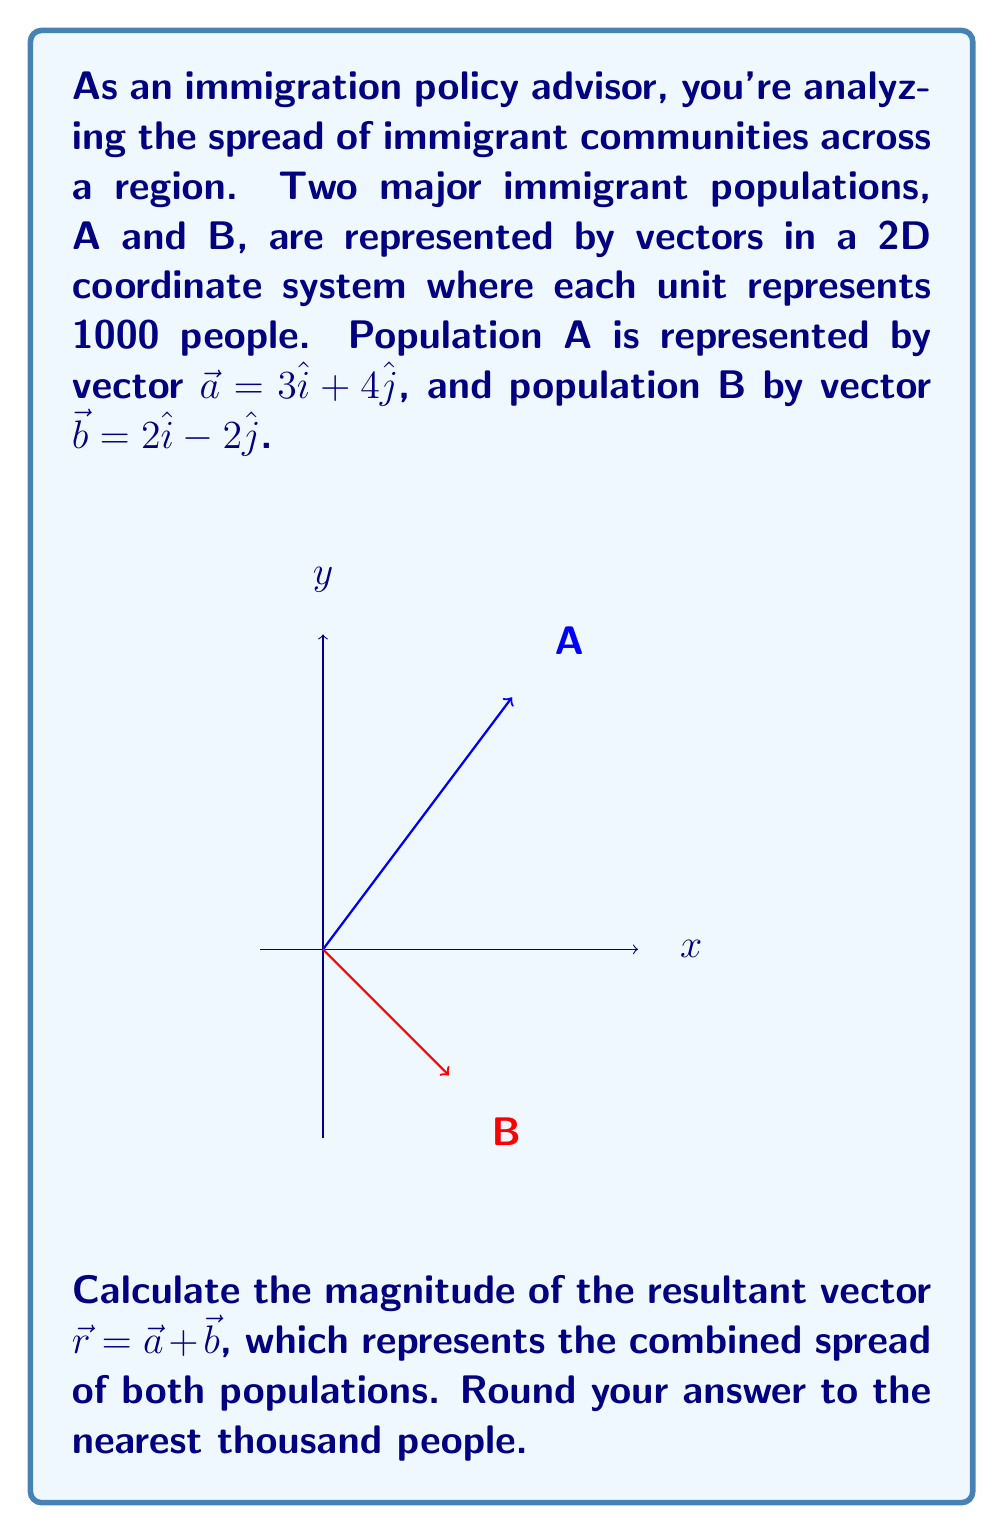Solve this math problem. Let's approach this step-by-step:

1) First, we need to add the two vectors $\vec{a}$ and $\vec{b}$:

   $\vec{r} = \vec{a} + \vec{b} = (3\hat{i} + 4\hat{j}) + (2\hat{i} - 2\hat{j})$

2) Combining like terms:

   $\vec{r} = (3+2)\hat{i} + (4-2)\hat{j} = 5\hat{i} + 2\hat{j}$

3) Now we have the resultant vector $\vec{r} = 5\hat{i} + 2\hat{j}$

4) To find the magnitude of this vector, we use the Pythagorean theorem:

   $|\vec{r}| = \sqrt{x^2 + y^2} = \sqrt{5^2 + 2^2}$

5) Calculating:

   $|\vec{r}| = \sqrt{25 + 4} = \sqrt{29}$

6) $\sqrt{29} \approx 5.385$

7) Remember, each unit represents 1000 people. So we multiply by 1000:

   $5.385 \times 1000 = 5385$ people

8) Rounding to the nearest thousand:

   $5385$ rounds to $5000$ people
Answer: 5000 people 